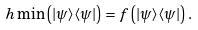Convert formula to latex. <formula><loc_0><loc_0><loc_500><loc_500>\ h \min \left ( | \psi \rangle \langle \psi | \right ) = f \left ( | \psi \rangle \langle \psi | \right ) .</formula> 